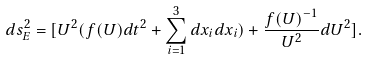<formula> <loc_0><loc_0><loc_500><loc_500>d s _ { E } ^ { 2 } = [ U ^ { 2 } ( f ( U ) d t ^ { 2 } + \sum _ { i = 1 } ^ { 3 } d x _ { i } d x _ { i } ) + \frac { f ( U ) ^ { - 1 } } { U ^ { 2 } } d U ^ { 2 } ] .</formula> 